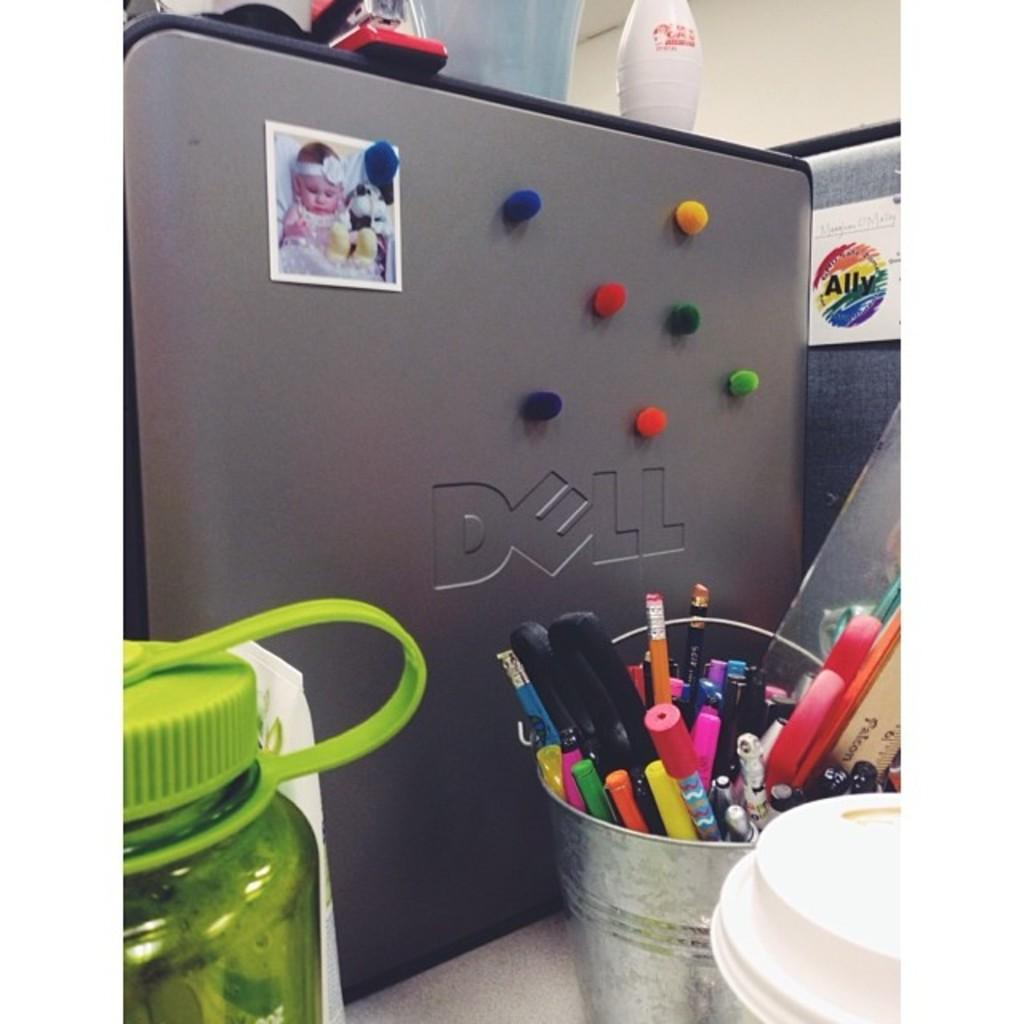Provide a one-sentence caption for the provided image. The Dell computer tower is decorated with colorful fuzzy balls. 